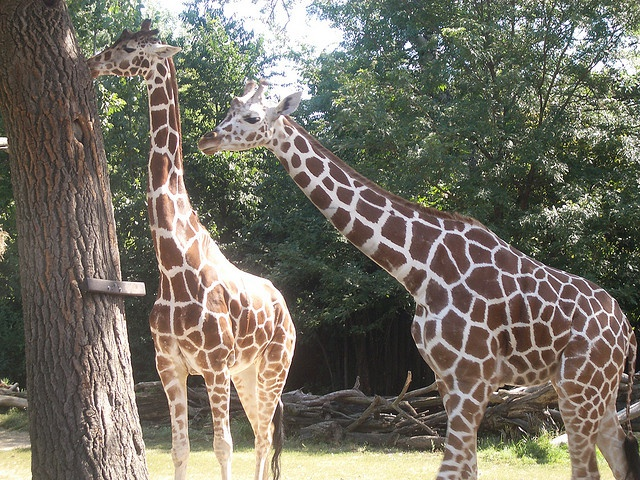Describe the objects in this image and their specific colors. I can see giraffe in black, gray, darkgray, lightgray, and maroon tones and giraffe in black, ivory, gray, and tan tones in this image. 